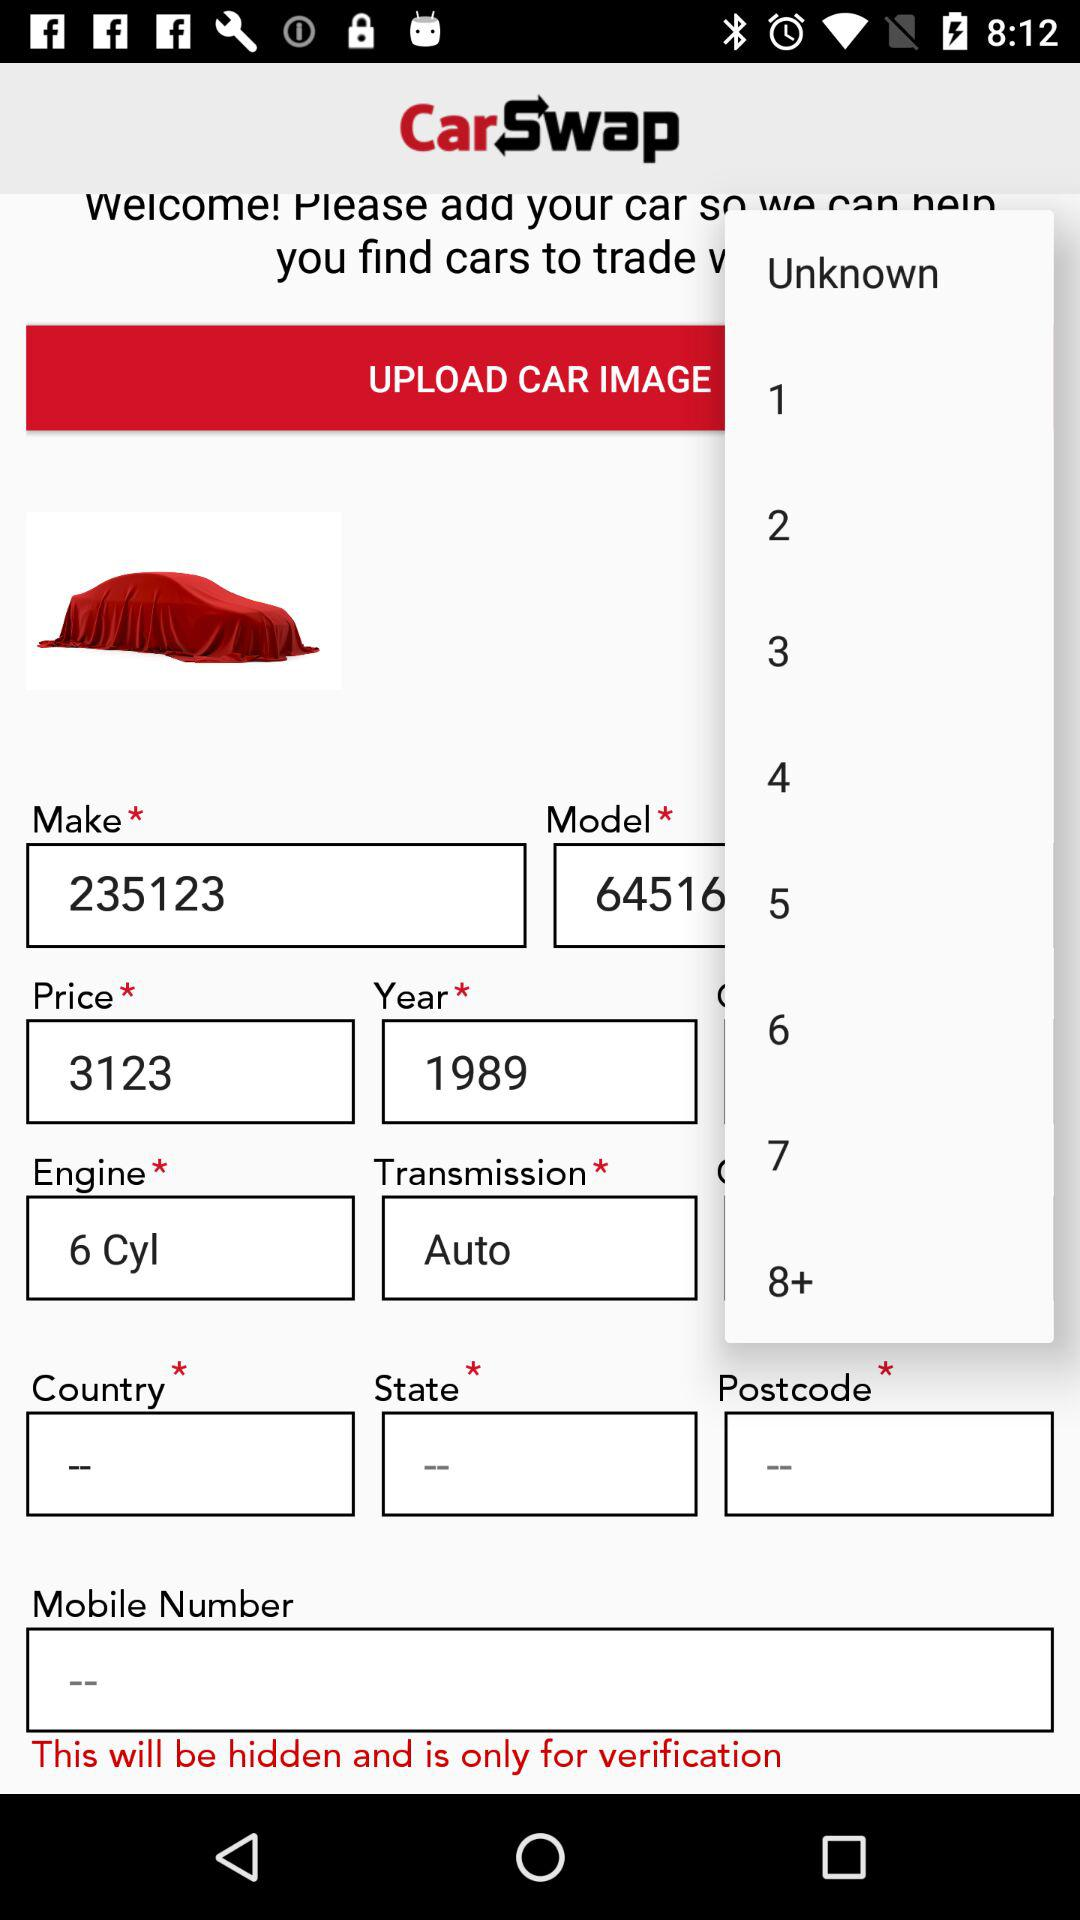What is the model number?
When the provided information is insufficient, respond with <no answer>. <no answer> 